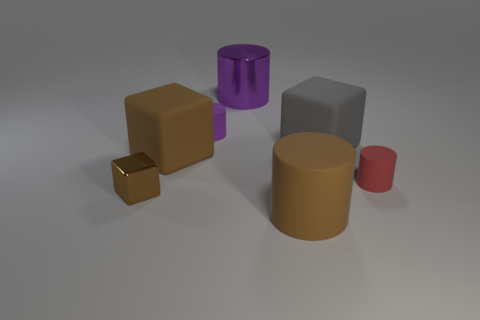Add 1 small red things. How many objects exist? 8 Subtract all cubes. How many objects are left? 4 Subtract all tiny brown shiny blocks. Subtract all tiny gray spheres. How many objects are left? 6 Add 4 shiny things. How many shiny things are left? 6 Add 3 small purple rubber objects. How many small purple rubber objects exist? 4 Subtract 0 purple balls. How many objects are left? 7 